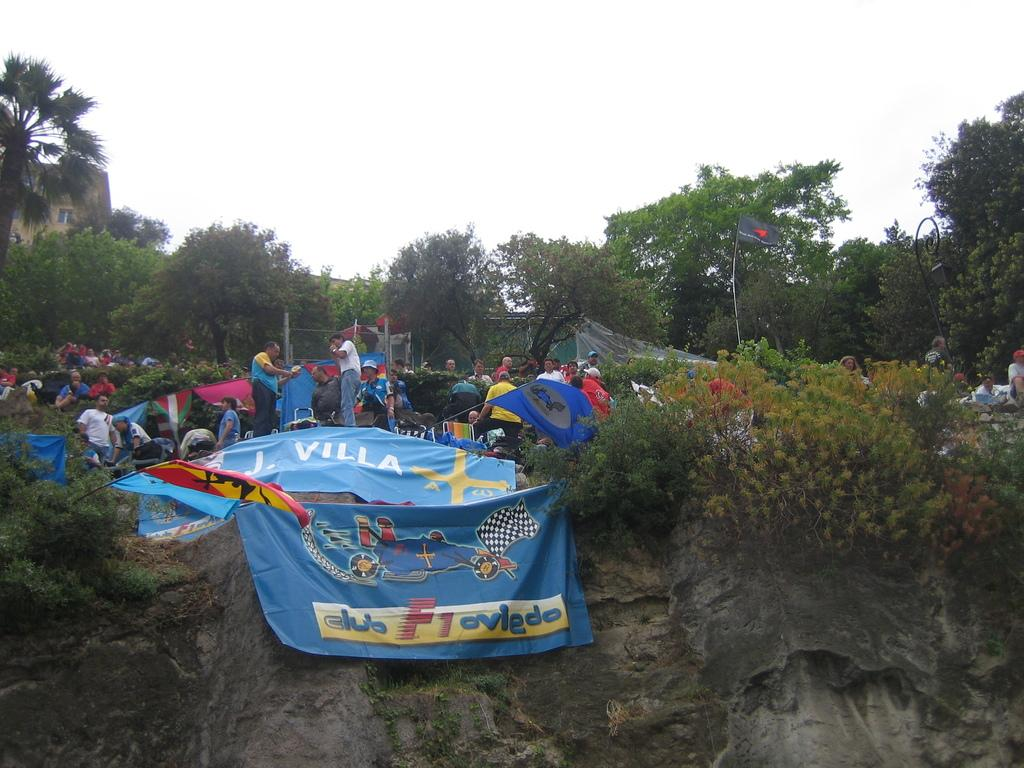What is happening in the image? There are people standing in the image. What can be seen near the people? There are flags and trees in the vicinity of the people. What direction are the trains moving in the image? There are no trains present in the image. 